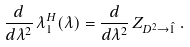<formula> <loc_0><loc_0><loc_500><loc_500>\frac { d } { d \lambda ^ { 2 } } \, \lambda _ { 1 } ^ { H } ( \lambda ) = \frac { d } { d \lambda ^ { 2 } } \, Z _ { D ^ { 2 } \to \hat { 1 } } \, .</formula> 